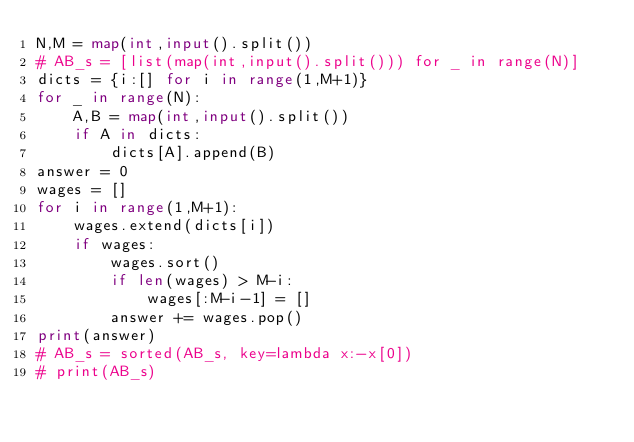<code> <loc_0><loc_0><loc_500><loc_500><_Python_>N,M = map(int,input().split())
# AB_s = [list(map(int,input().split())) for _ in range(N)]
dicts = {i:[] for i in range(1,M+1)}
for _ in range(N):
    A,B = map(int,input().split())
    if A in dicts:
        dicts[A].append(B)
answer = 0
wages = []
for i in range(1,M+1):
    wages.extend(dicts[i])
    if wages:
        wages.sort()
        if len(wages) > M-i:
            wages[:M-i-1] = []
        answer += wages.pop()
print(answer)
# AB_s = sorted(AB_s, key=lambda x:-x[0])
# print(AB_s)</code> 